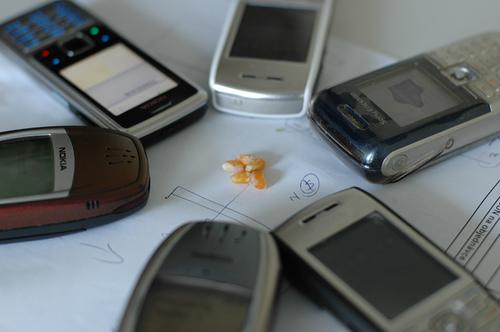What does the item in the middle of the phones look like?

Choices:
A) umbrella
B) marshmallow
C) jelly beans
D) baby jelly beans 